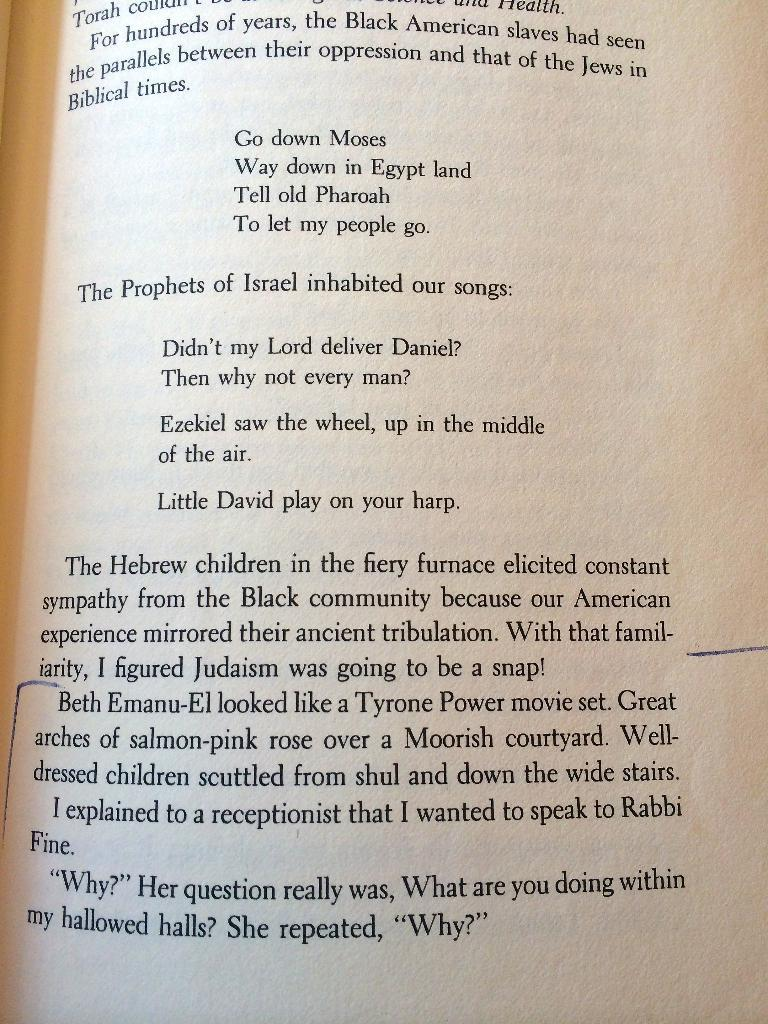Provide a one-sentence caption for the provided image. Chapter book that have information about Israel and black american slaves. 